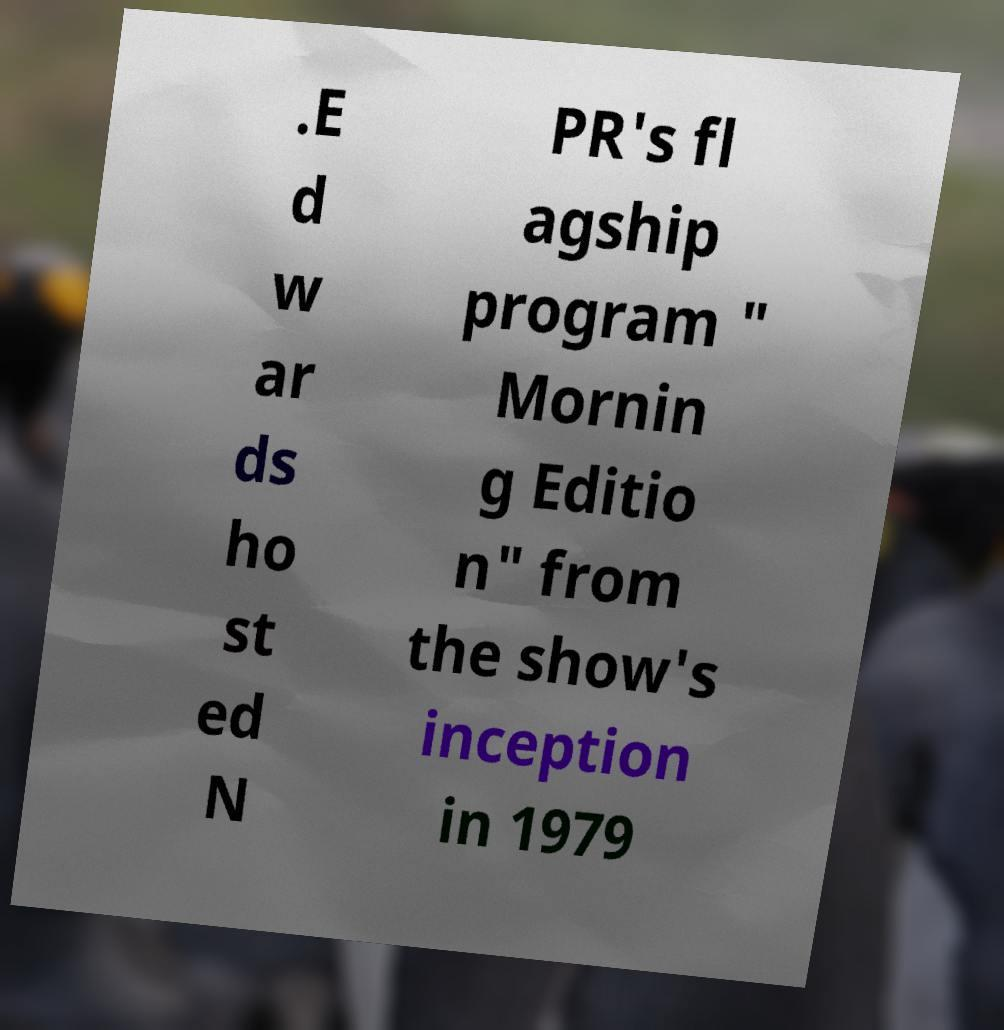Please read and relay the text visible in this image. What does it say? .E d w ar ds ho st ed N PR's fl agship program " Mornin g Editio n" from the show's inception in 1979 